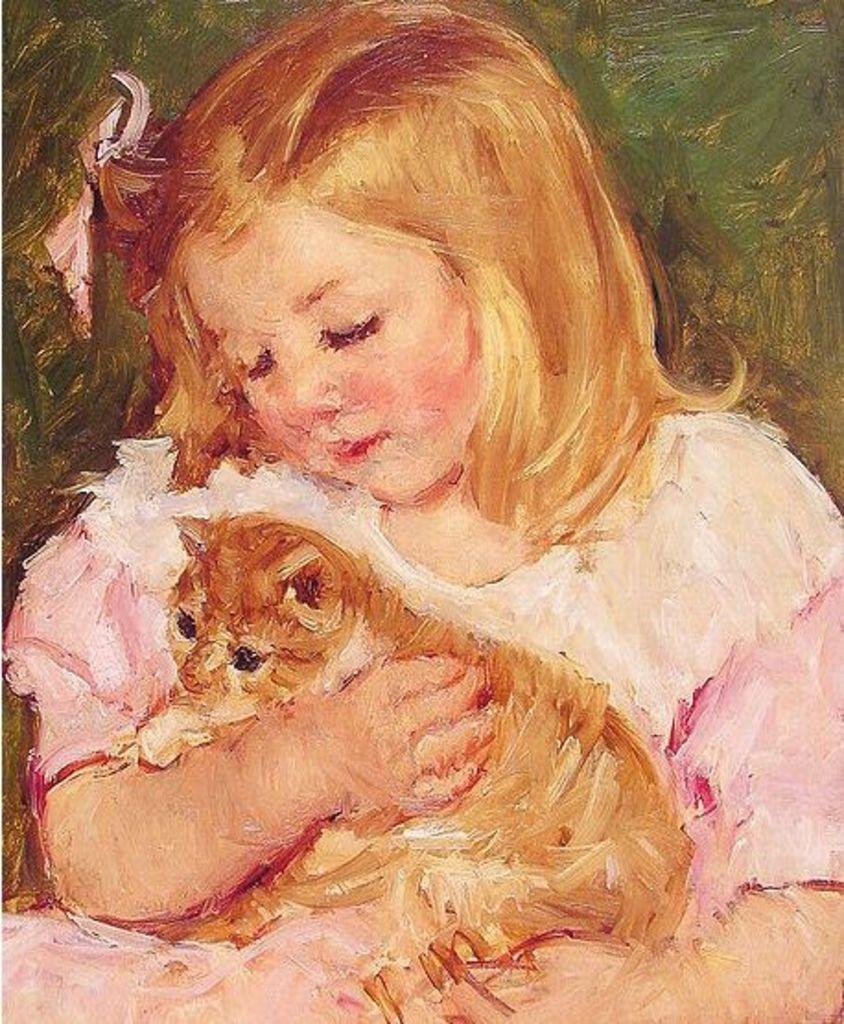What type of artwork is depicted in the image? The image is a painting. What is the main subject of the painting? There is a kid in the painting. What is the kid holding in the painting? The kid is holding a cat. What type of protest is happening in the painting? There is no protest depicted in the painting; it features a kid holding a cat. Can you tell me where the hospital is located in the painting? There is no hospital present in the painting; it features a kid holding a cat. 